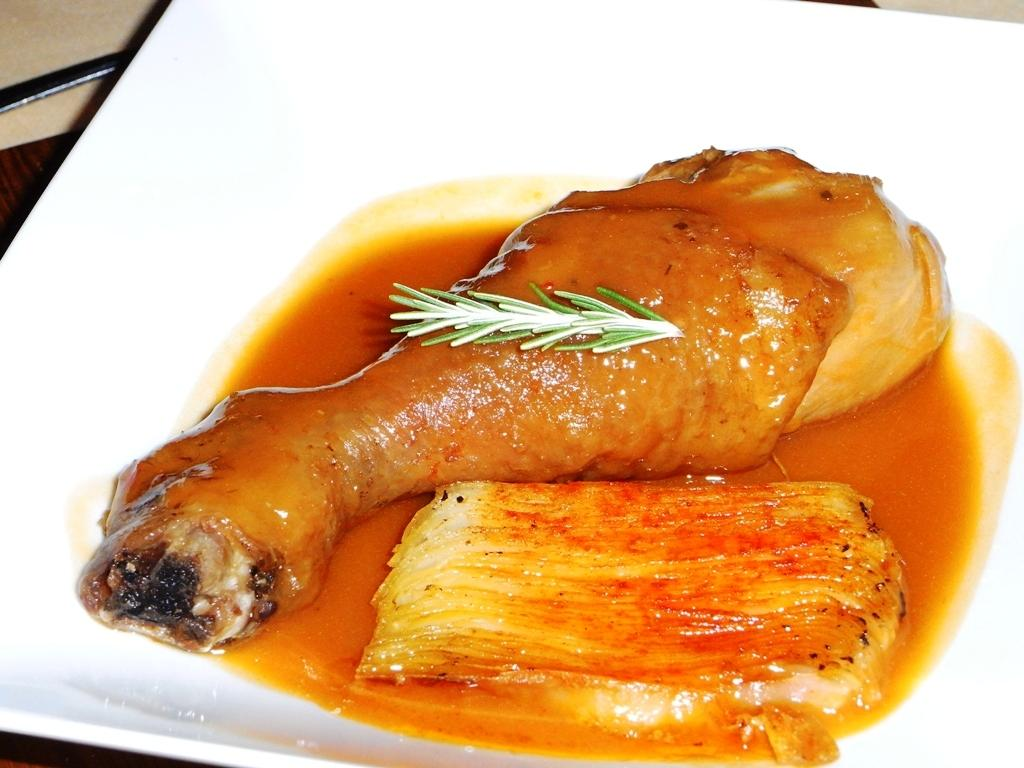What object is present on the plate in the image? There is a food item on the plate in the image. What color is the plate in the image? The plate in the image is white. What type of magic is being performed by the queen in the image? There is no queen or magic present in the image; it only features a white plate with a food item on it. 